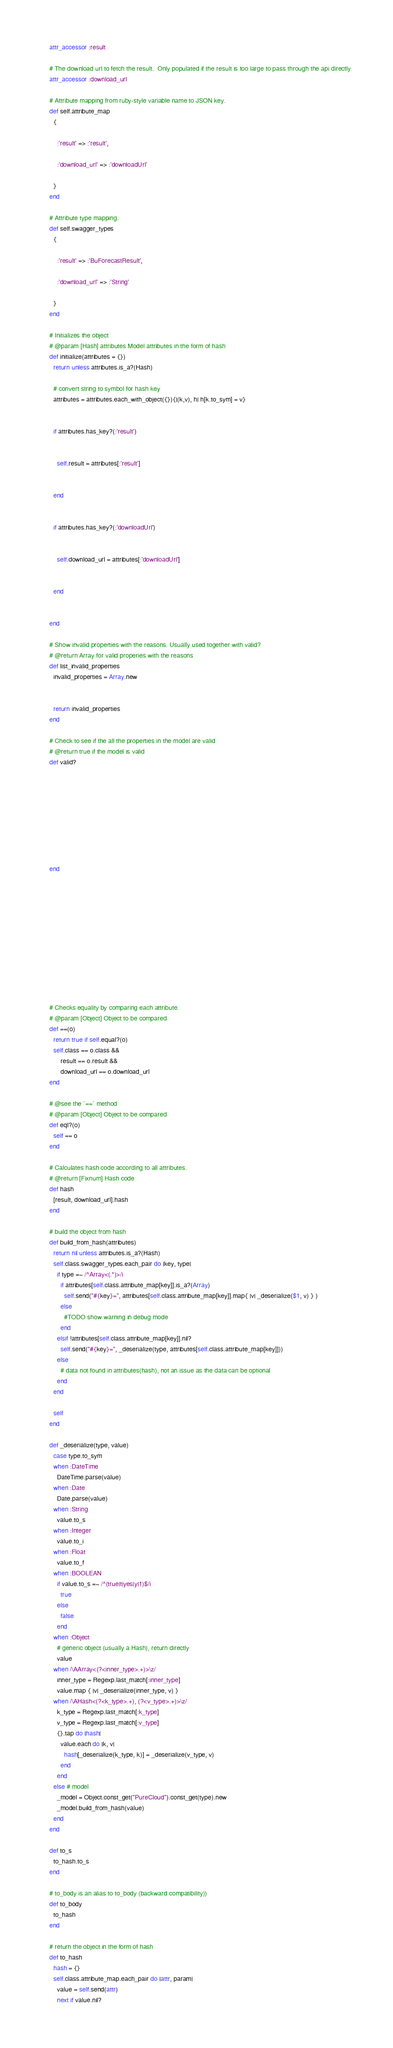<code> <loc_0><loc_0><loc_500><loc_500><_Ruby_>    attr_accessor :result

    # The download url to fetch the result.  Only populated if the result is too large to pass through the api directly
    attr_accessor :download_url

    # Attribute mapping from ruby-style variable name to JSON key.
    def self.attribute_map
      {
        
        :'result' => :'result',
        
        :'download_url' => :'downloadUrl'
        
      }
    end

    # Attribute type mapping.
    def self.swagger_types
      {
        
        :'result' => :'BuForecastResult',
        
        :'download_url' => :'String'
        
      }
    end

    # Initializes the object
    # @param [Hash] attributes Model attributes in the form of hash
    def initialize(attributes = {})
      return unless attributes.is_a?(Hash)

      # convert string to symbol for hash key
      attributes = attributes.each_with_object({}){|(k,v), h| h[k.to_sym] = v}

      
      if attributes.has_key?(:'result')
        
        
        self.result = attributes[:'result']
        
      
      end

      
      if attributes.has_key?(:'downloadUrl')
        
        
        self.download_url = attributes[:'downloadUrl']
        
      
      end

      
    end

    # Show invalid properties with the reasons. Usually used together with valid?
    # @return Array for valid properies with the reasons
    def list_invalid_properties
      invalid_properties = Array.new
      
      
      return invalid_properties
    end

    # Check to see if the all the properties in the model are valid
    # @return true if the model is valid
    def valid?
      
      
      
      
      
      
      
      
      
    end

    
    
    
    
    
    
    
    
    
    
    
    # Checks equality by comparing each attribute.
    # @param [Object] Object to be compared
    def ==(o)
      return true if self.equal?(o)
      self.class == o.class &&
          result == o.result &&
          download_url == o.download_url
    end

    # @see the `==` method
    # @param [Object] Object to be compared
    def eql?(o)
      self == o
    end

    # Calculates hash code according to all attributes.
    # @return [Fixnum] Hash code
    def hash
      [result, download_url].hash
    end

    # build the object from hash
    def build_from_hash(attributes)
      return nil unless attributes.is_a?(Hash)
      self.class.swagger_types.each_pair do |key, type|
        if type =~ /^Array<(.*)>/i
          if attributes[self.class.attribute_map[key]].is_a?(Array)
            self.send("#{key}=", attributes[self.class.attribute_map[key]].map{ |v| _deserialize($1, v) } )
          else
            #TODO show warning in debug mode
          end
        elsif !attributes[self.class.attribute_map[key]].nil?
          self.send("#{key}=", _deserialize(type, attributes[self.class.attribute_map[key]]))
        else
          # data not found in attributes(hash), not an issue as the data can be optional
        end
      end

      self
    end

    def _deserialize(type, value)
      case type.to_sym
      when :DateTime
        DateTime.parse(value)
      when :Date
        Date.parse(value)
      when :String
        value.to_s
      when :Integer
        value.to_i
      when :Float
        value.to_f
      when :BOOLEAN
        if value.to_s =~ /^(true|t|yes|y|1)$/i
          true
        else
          false
        end
      when :Object
        # generic object (usually a Hash), return directly
        value
      when /\AArray<(?<inner_type>.+)>\z/
        inner_type = Regexp.last_match[:inner_type]
        value.map { |v| _deserialize(inner_type, v) }
      when /\AHash<(?<k_type>.+), (?<v_type>.+)>\z/
        k_type = Regexp.last_match[:k_type]
        v_type = Regexp.last_match[:v_type]
        {}.tap do |hash|
          value.each do |k, v|
            hash[_deserialize(k_type, k)] = _deserialize(v_type, v)
          end
        end
      else # model
        _model = Object.const_get("PureCloud").const_get(type).new
        _model.build_from_hash(value)
      end
    end

    def to_s
      to_hash.to_s
    end

    # to_body is an alias to to_body (backward compatibility))
    def to_body
      to_hash
    end

    # return the object in the form of hash
    def to_hash
      hash = {}
      self.class.attribute_map.each_pair do |attr, param|
        value = self.send(attr)
        next if value.nil?</code> 